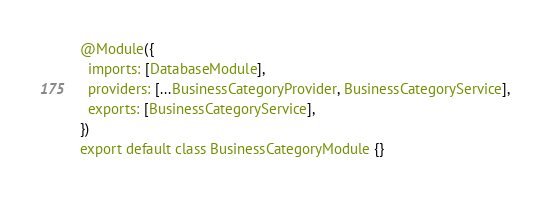Convert code to text. <code><loc_0><loc_0><loc_500><loc_500><_TypeScript_>
@Module({
  imports: [DatabaseModule],
  providers: [...BusinessCategoryProvider, BusinessCategoryService],
  exports: [BusinessCategoryService],
})
export default class BusinessCategoryModule {}
</code> 